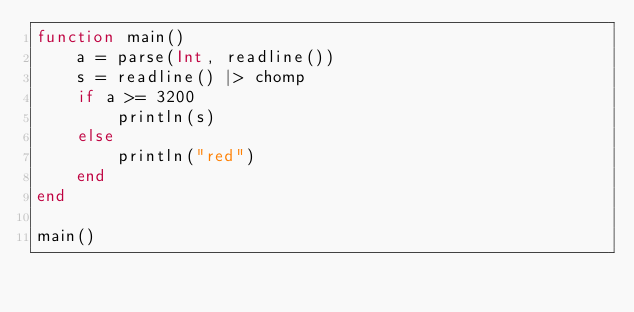Convert code to text. <code><loc_0><loc_0><loc_500><loc_500><_Julia_>function main()
    a = parse(Int, readline())
    s = readline() |> chomp
    if a >= 3200
        println(s)
    else
        println("red")
    end
end

main()</code> 